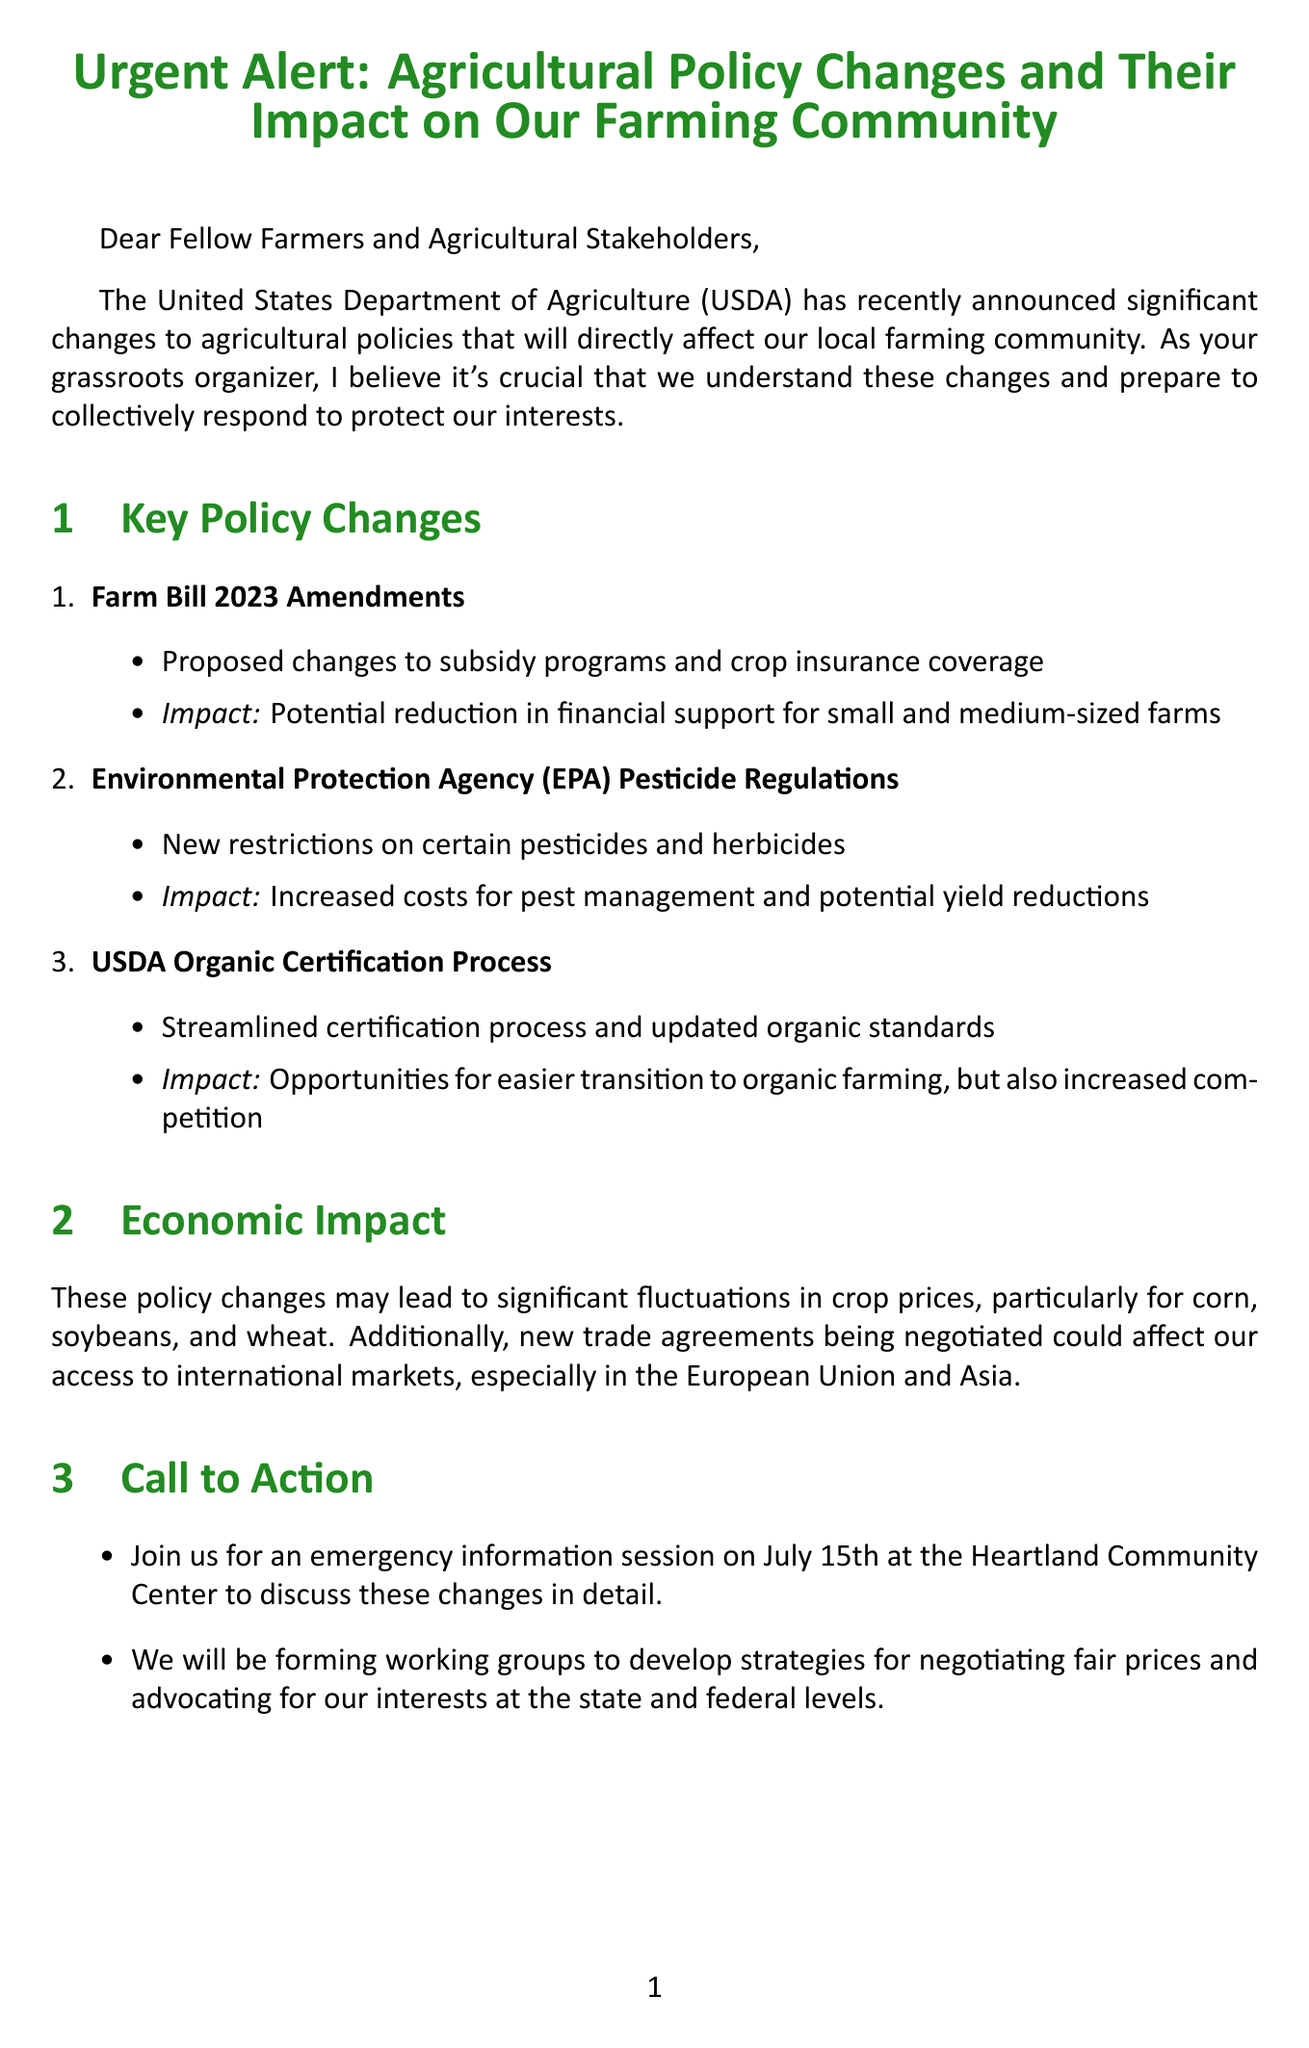What is the title of the letter? The title is the main topic of the letter, which introduces the subject addressed to the audience.
Answer: Urgent Alert: Agricultural Policy Changes and Their Impact on Our Farming Community When is the emergency information session scheduled? The date mentioned for the information session reveals when farmers can gather to discuss the changes.
Answer: July 15th What department announced the agricultural policy changes? The document identifies the responsible governmental organization for the announcement.
Answer: United States Department of Agriculture (USDA) What is one proposed change in the Farm Bill 2023 Amendments? This question seeks a specific change recommended in the Farm Bill as outlined in the policy changes section.
Answer: Changes to subsidy programs What are the potential impacts of the EPA pesticide regulations? Understanding the consequences of these regulations helps gauge their effect on farmers' operations.
Answer: Increased costs for pest management and potential yield reductions What is the main message in the closing of the letter? The closing reinforces the document’s theme of unity and collaboration among farmers.
Answer: Our strength lies in our unity What organization provides up-to-date policy information? This question targets a resource mentioned in the letter that supports farmers with policy updates.
Answer: National Farmers Union (NFU) What type of farming opportunity is mentioned in the USDA Organic Certification Process? This question assesses knowledge of the potential benefits of a specific policy mentioned in the letter.
Answer: Easier transition to organic farming How may crop prices be affected according to the economic impact section? This question requires connecting the policy changes to their economic consequences on farmers.
Answer: Significant fluctuations in crop prices 